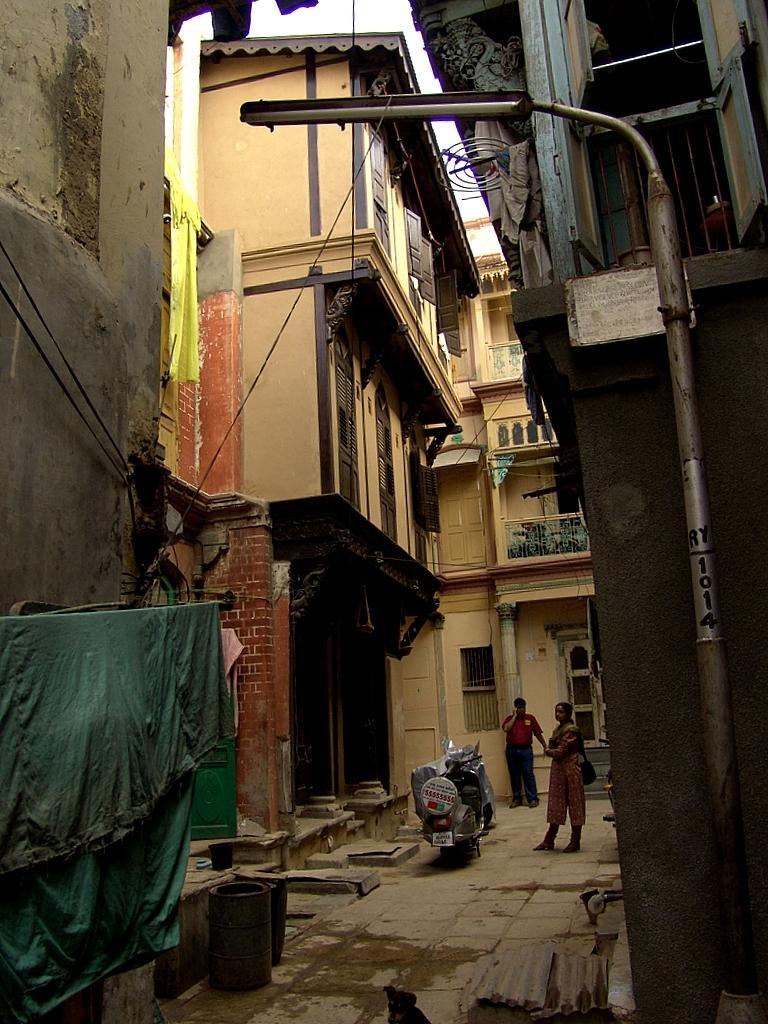In one or two sentences, can you explain what this image depicts? In the image we can see some buildings and poles and clothes. In the middle of the image there are some motorcycles and two persons are standing. 